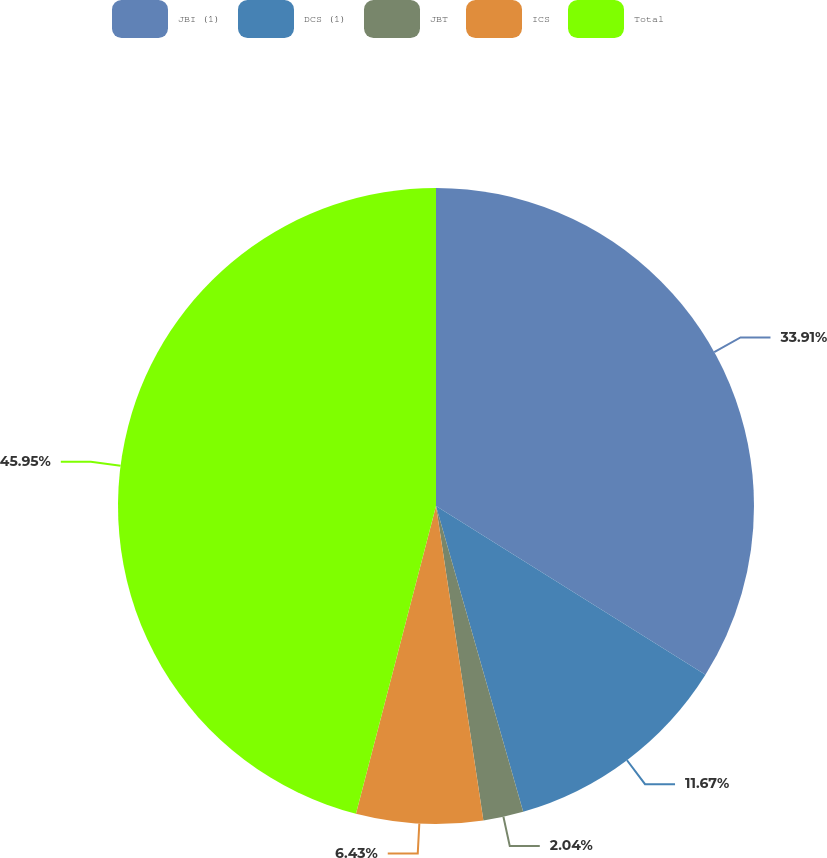Convert chart to OTSL. <chart><loc_0><loc_0><loc_500><loc_500><pie_chart><fcel>JBI (1)<fcel>DCS (1)<fcel>JBT<fcel>ICS<fcel>Total<nl><fcel>33.91%<fcel>11.67%<fcel>2.04%<fcel>6.43%<fcel>45.95%<nl></chart> 